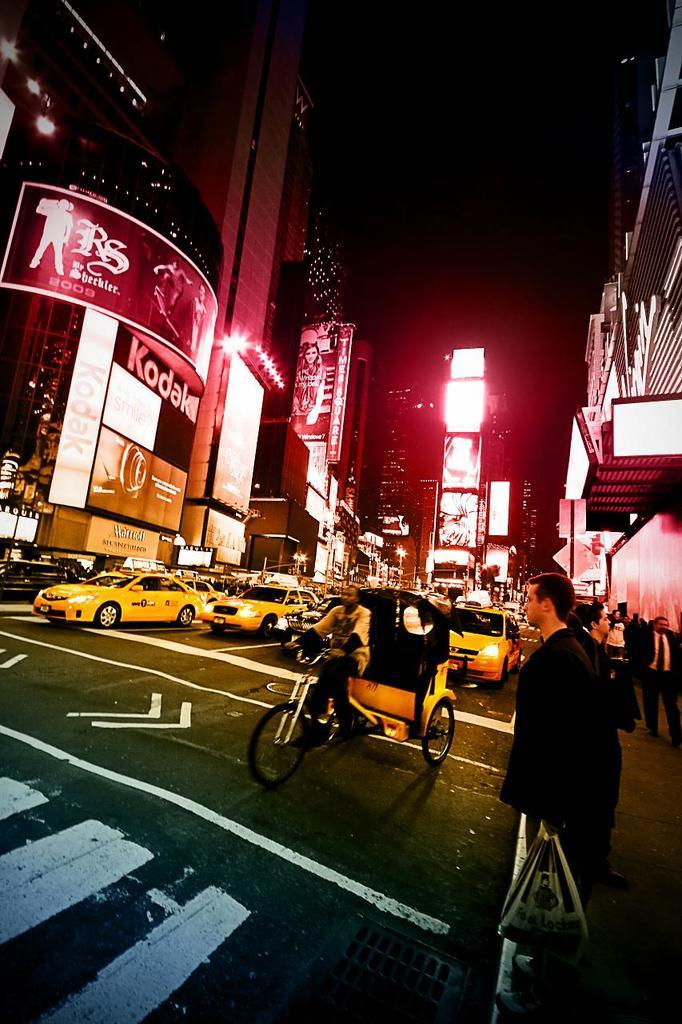What is the main subject in the image? There is a person standing in the image. What is the person holding in the image? The person is holding a carry bag. What can be seen in the background of the image? Large buildings are visible in the image. What is happening in the foreground of the image? Cars are moving on the road in the image. Are there any dinosaurs visible in the image? No, there are no dinosaurs present in the image. What type of structure is the person pushing in the image? There is no structure being pushed in the image; the person is simply standing and holding a carry bag. 